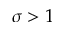Convert formula to latex. <formula><loc_0><loc_0><loc_500><loc_500>\sigma > 1</formula> 